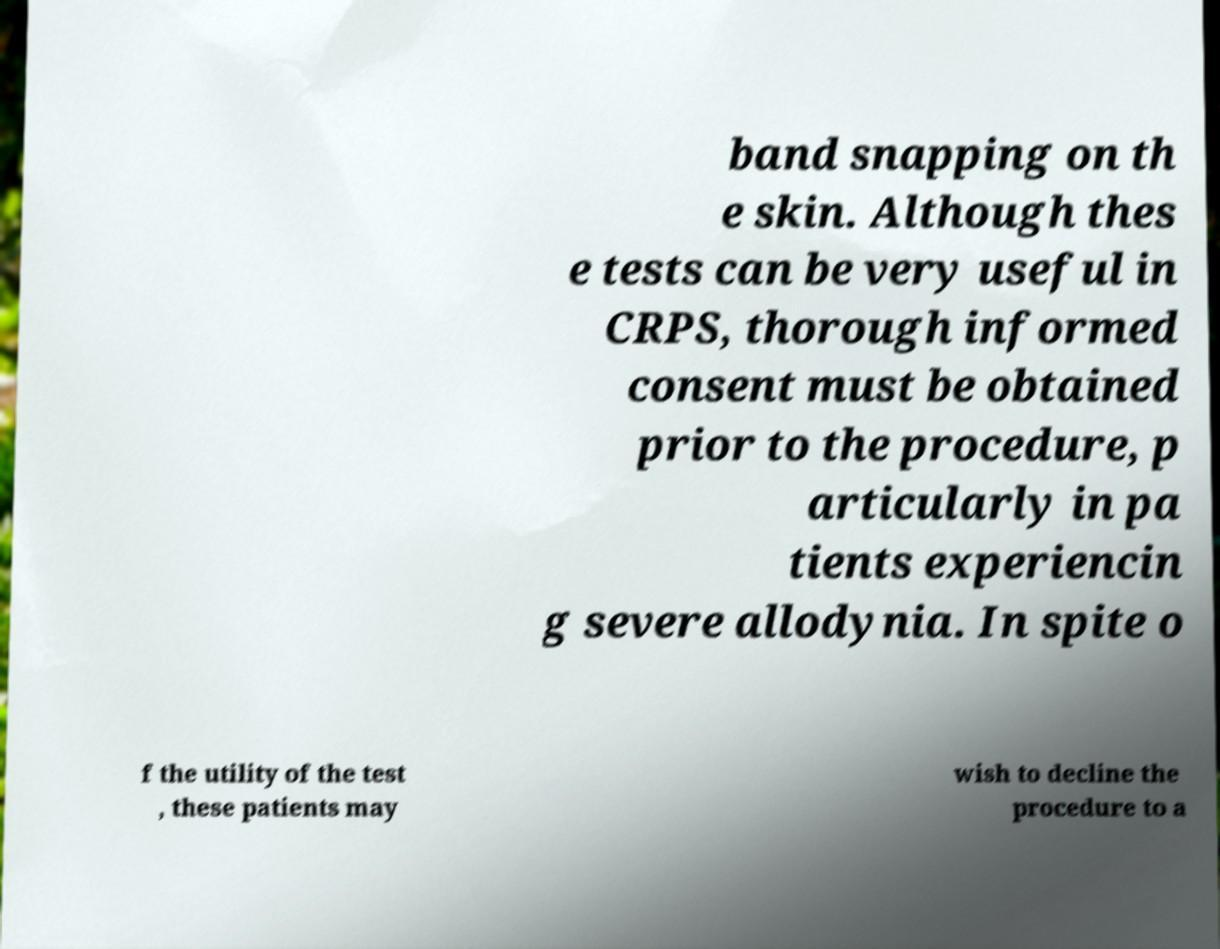Can you read and provide the text displayed in the image?This photo seems to have some interesting text. Can you extract and type it out for me? band snapping on th e skin. Although thes e tests can be very useful in CRPS, thorough informed consent must be obtained prior to the procedure, p articularly in pa tients experiencin g severe allodynia. In spite o f the utility of the test , these patients may wish to decline the procedure to a 